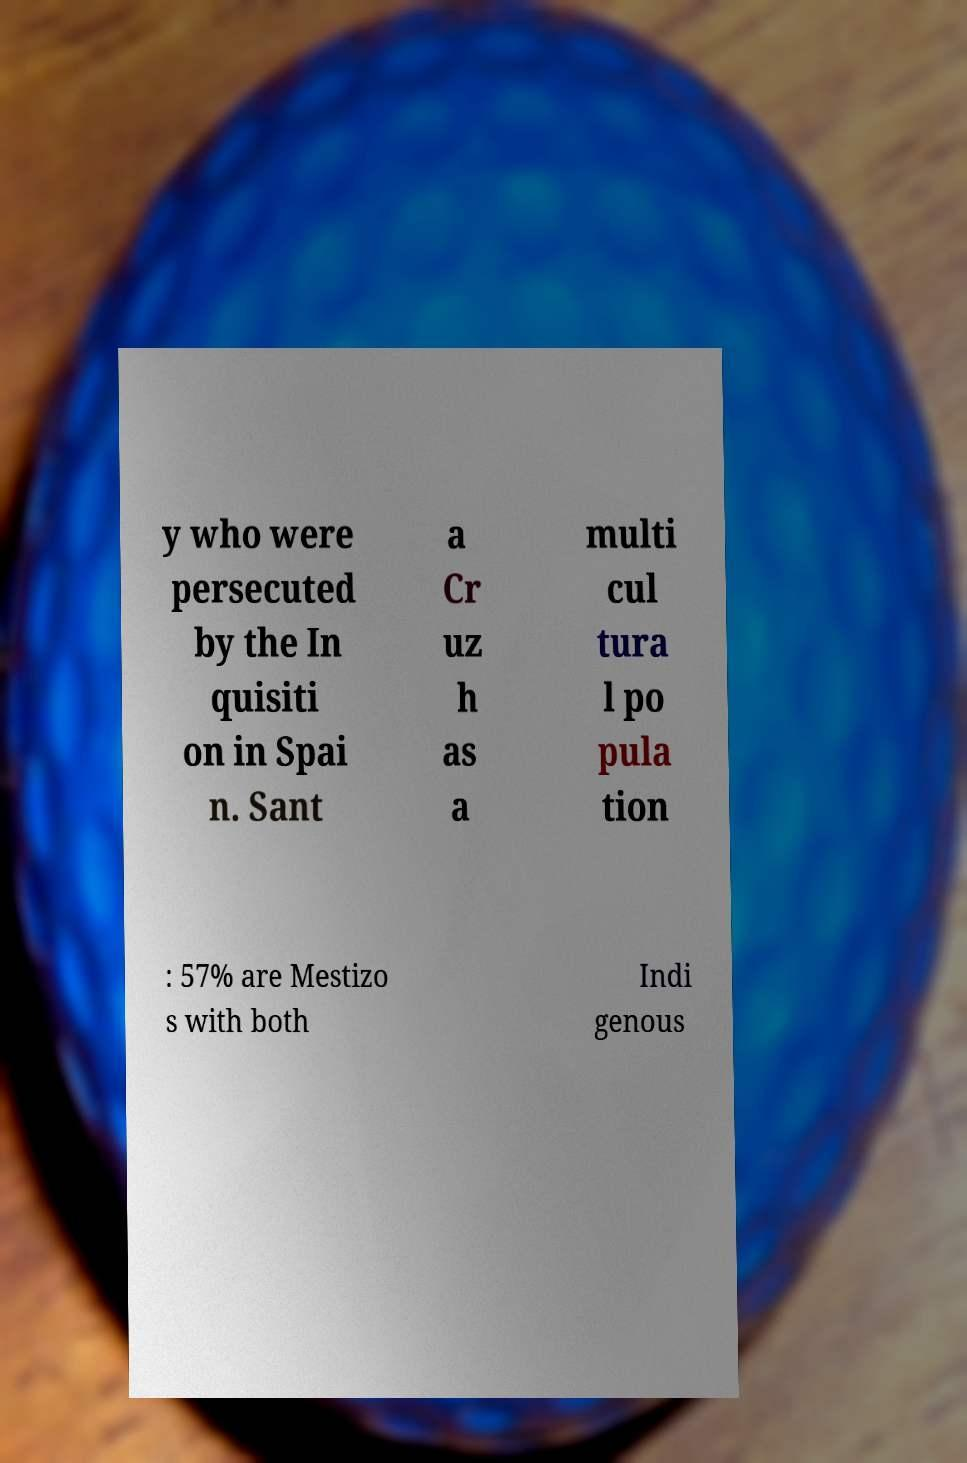What messages or text are displayed in this image? I need them in a readable, typed format. y who were persecuted by the In quisiti on in Spai n. Sant a Cr uz h as a multi cul tura l po pula tion : 57% are Mestizo s with both Indi genous 